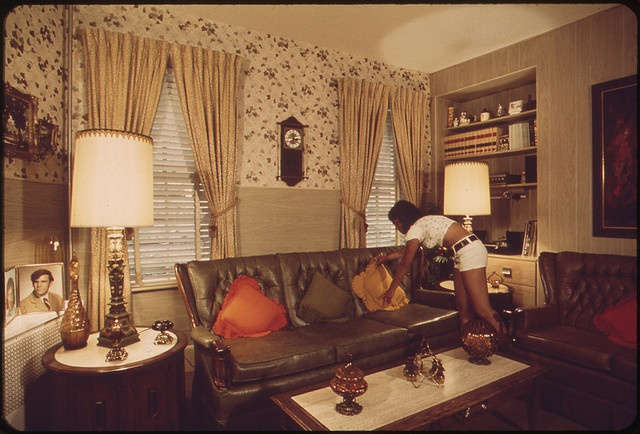Describe the objects in this image and their specific colors. I can see couch in black, maroon, and brown tones, couch in black, maroon, and brown tones, people in black, maroon, tan, and brown tones, book in black, maroon, gray, brown, and tan tones, and bottle in black, brown, and maroon tones in this image. 